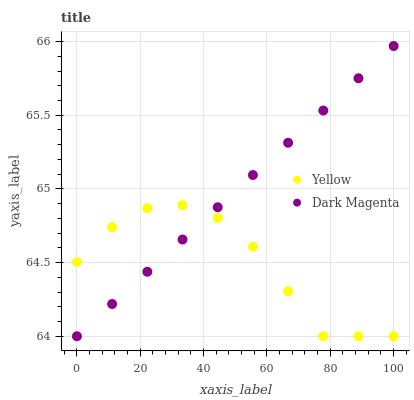Does Yellow have the minimum area under the curve?
Answer yes or no. Yes. Does Dark Magenta have the maximum area under the curve?
Answer yes or no. Yes. Does Yellow have the maximum area under the curve?
Answer yes or no. No. Is Dark Magenta the smoothest?
Answer yes or no. Yes. Is Yellow the roughest?
Answer yes or no. Yes. Is Yellow the smoothest?
Answer yes or no. No. Does Dark Magenta have the lowest value?
Answer yes or no. Yes. Does Dark Magenta have the highest value?
Answer yes or no. Yes. Does Yellow have the highest value?
Answer yes or no. No. Does Yellow intersect Dark Magenta?
Answer yes or no. Yes. Is Yellow less than Dark Magenta?
Answer yes or no. No. Is Yellow greater than Dark Magenta?
Answer yes or no. No. 